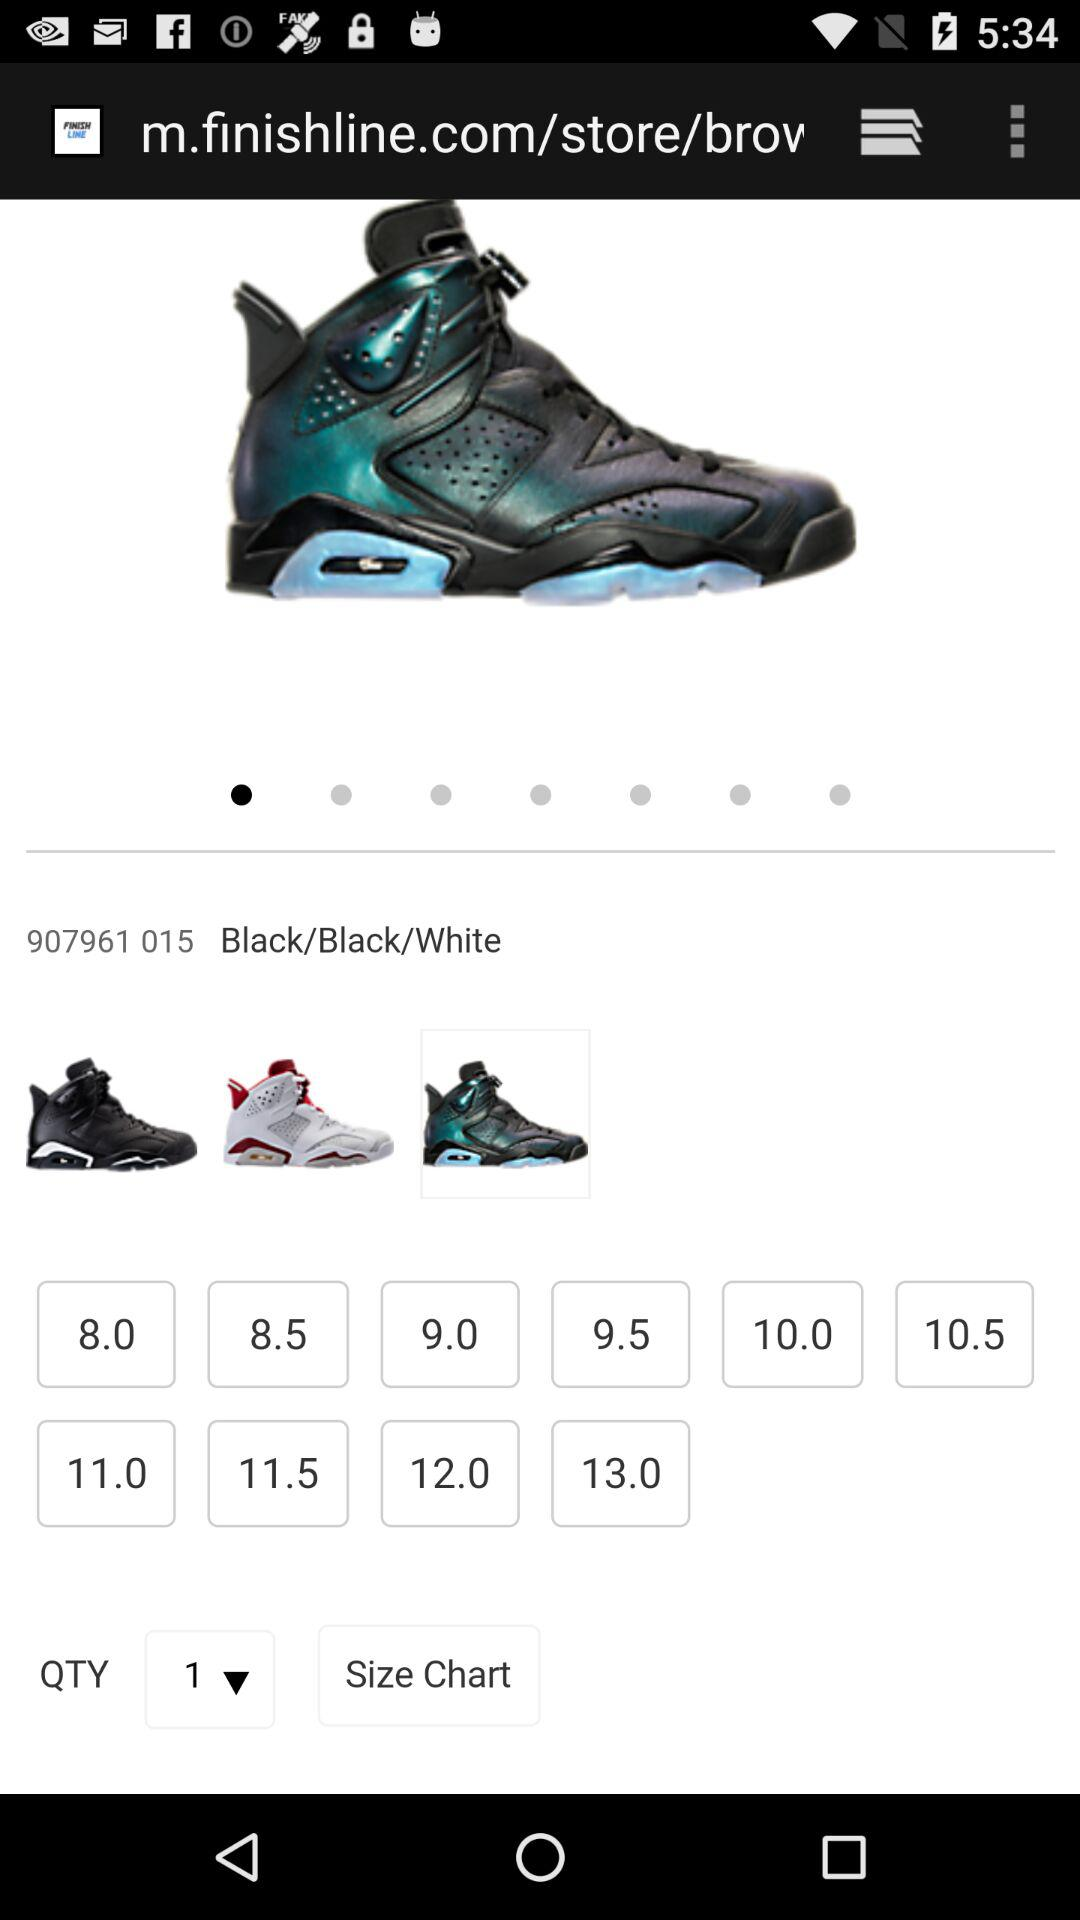What is the QTY? The QTY is 1. 